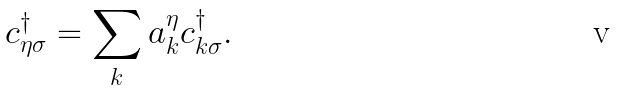<formula> <loc_0><loc_0><loc_500><loc_500>c _ { \eta \sigma } ^ { \dagger } = \sum _ { k } a _ { k } ^ { \eta } c _ { { k } \sigma } ^ { \dagger } .</formula> 